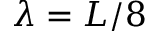Convert formula to latex. <formula><loc_0><loc_0><loc_500><loc_500>\lambda = L / 8</formula> 